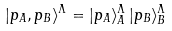Convert formula to latex. <formula><loc_0><loc_0><loc_500><loc_500>| { p } _ { A } , { p } _ { B } \rangle ^ { \Lambda } = | { p } _ { A } \rangle _ { A } ^ { \Lambda } \, | { p } _ { B } \rangle _ { B } ^ { \Lambda }</formula> 